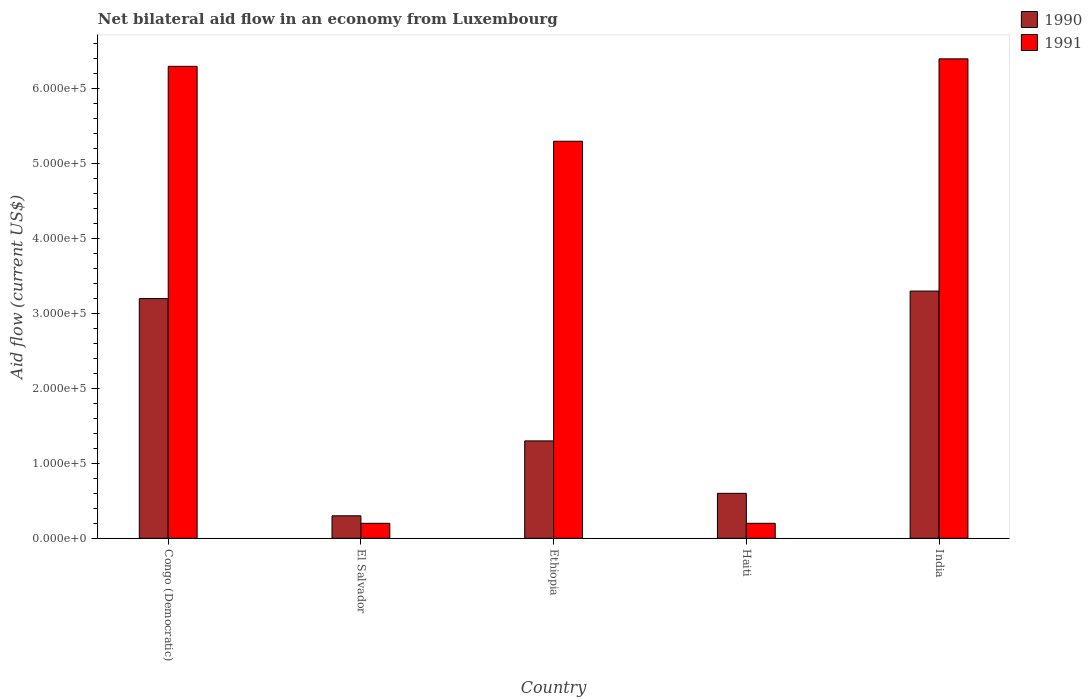How many groups of bars are there?
Offer a very short reply. 5. Are the number of bars per tick equal to the number of legend labels?
Your answer should be compact. Yes. Are the number of bars on each tick of the X-axis equal?
Keep it short and to the point. Yes. How many bars are there on the 4th tick from the left?
Your response must be concise. 2. How many bars are there on the 5th tick from the right?
Offer a terse response. 2. What is the label of the 2nd group of bars from the left?
Your answer should be very brief. El Salvador. What is the net bilateral aid flow in 1990 in Ethiopia?
Make the answer very short. 1.30e+05. In which country was the net bilateral aid flow in 1991 minimum?
Give a very brief answer. El Salvador. What is the total net bilateral aid flow in 1991 in the graph?
Offer a very short reply. 1.84e+06. What is the difference between the net bilateral aid flow in 1991 in Haiti and that in India?
Your answer should be compact. -6.20e+05. What is the average net bilateral aid flow in 1991 per country?
Give a very brief answer. 3.68e+05. What is the difference between the net bilateral aid flow of/in 1991 and net bilateral aid flow of/in 1990 in India?
Make the answer very short. 3.10e+05. What is the ratio of the net bilateral aid flow in 1990 in Congo (Democratic) to that in India?
Make the answer very short. 0.97. Is the net bilateral aid flow in 1990 in Congo (Democratic) less than that in Ethiopia?
Make the answer very short. No. What is the difference between the highest and the lowest net bilateral aid flow in 1990?
Your answer should be compact. 3.00e+05. In how many countries, is the net bilateral aid flow in 1991 greater than the average net bilateral aid flow in 1991 taken over all countries?
Keep it short and to the point. 3. What does the 1st bar from the right in Ethiopia represents?
Ensure brevity in your answer.  1991. Are all the bars in the graph horizontal?
Provide a short and direct response. No. How many countries are there in the graph?
Give a very brief answer. 5. Does the graph contain any zero values?
Offer a very short reply. No. Where does the legend appear in the graph?
Offer a terse response. Top right. How many legend labels are there?
Provide a succinct answer. 2. What is the title of the graph?
Provide a succinct answer. Net bilateral aid flow in an economy from Luxembourg. Does "1990" appear as one of the legend labels in the graph?
Ensure brevity in your answer.  Yes. What is the label or title of the X-axis?
Ensure brevity in your answer.  Country. What is the label or title of the Y-axis?
Provide a short and direct response. Aid flow (current US$). What is the Aid flow (current US$) of 1991 in Congo (Democratic)?
Your response must be concise. 6.30e+05. What is the Aid flow (current US$) in 1990 in El Salvador?
Ensure brevity in your answer.  3.00e+04. What is the Aid flow (current US$) in 1991 in Ethiopia?
Your response must be concise. 5.30e+05. What is the Aid flow (current US$) in 1990 in Haiti?
Keep it short and to the point. 6.00e+04. What is the Aid flow (current US$) of 1991 in Haiti?
Provide a short and direct response. 2.00e+04. What is the Aid flow (current US$) in 1991 in India?
Your response must be concise. 6.40e+05. Across all countries, what is the maximum Aid flow (current US$) of 1990?
Your response must be concise. 3.30e+05. Across all countries, what is the maximum Aid flow (current US$) of 1991?
Ensure brevity in your answer.  6.40e+05. What is the total Aid flow (current US$) in 1990 in the graph?
Keep it short and to the point. 8.70e+05. What is the total Aid flow (current US$) of 1991 in the graph?
Give a very brief answer. 1.84e+06. What is the difference between the Aid flow (current US$) of 1990 in Congo (Democratic) and that in El Salvador?
Offer a terse response. 2.90e+05. What is the difference between the Aid flow (current US$) in 1991 in Congo (Democratic) and that in El Salvador?
Offer a terse response. 6.10e+05. What is the difference between the Aid flow (current US$) of 1990 in Congo (Democratic) and that in Haiti?
Give a very brief answer. 2.60e+05. What is the difference between the Aid flow (current US$) in 1990 in El Salvador and that in Ethiopia?
Make the answer very short. -1.00e+05. What is the difference between the Aid flow (current US$) in 1991 in El Salvador and that in Ethiopia?
Your response must be concise. -5.10e+05. What is the difference between the Aid flow (current US$) in 1990 in El Salvador and that in Haiti?
Your response must be concise. -3.00e+04. What is the difference between the Aid flow (current US$) in 1991 in El Salvador and that in Haiti?
Provide a short and direct response. 0. What is the difference between the Aid flow (current US$) in 1991 in El Salvador and that in India?
Your answer should be compact. -6.20e+05. What is the difference between the Aid flow (current US$) of 1991 in Ethiopia and that in Haiti?
Your response must be concise. 5.10e+05. What is the difference between the Aid flow (current US$) of 1991 in Ethiopia and that in India?
Provide a succinct answer. -1.10e+05. What is the difference between the Aid flow (current US$) of 1990 in Haiti and that in India?
Make the answer very short. -2.70e+05. What is the difference between the Aid flow (current US$) of 1991 in Haiti and that in India?
Your response must be concise. -6.20e+05. What is the difference between the Aid flow (current US$) of 1990 in Congo (Democratic) and the Aid flow (current US$) of 1991 in Ethiopia?
Your answer should be compact. -2.10e+05. What is the difference between the Aid flow (current US$) in 1990 in Congo (Democratic) and the Aid flow (current US$) in 1991 in Haiti?
Provide a succinct answer. 3.00e+05. What is the difference between the Aid flow (current US$) in 1990 in Congo (Democratic) and the Aid flow (current US$) in 1991 in India?
Ensure brevity in your answer.  -3.20e+05. What is the difference between the Aid flow (current US$) of 1990 in El Salvador and the Aid flow (current US$) of 1991 in Ethiopia?
Your answer should be very brief. -5.00e+05. What is the difference between the Aid flow (current US$) of 1990 in El Salvador and the Aid flow (current US$) of 1991 in Haiti?
Provide a short and direct response. 10000. What is the difference between the Aid flow (current US$) of 1990 in El Salvador and the Aid flow (current US$) of 1991 in India?
Make the answer very short. -6.10e+05. What is the difference between the Aid flow (current US$) in 1990 in Ethiopia and the Aid flow (current US$) in 1991 in India?
Give a very brief answer. -5.10e+05. What is the difference between the Aid flow (current US$) of 1990 in Haiti and the Aid flow (current US$) of 1991 in India?
Offer a terse response. -5.80e+05. What is the average Aid flow (current US$) of 1990 per country?
Make the answer very short. 1.74e+05. What is the average Aid flow (current US$) in 1991 per country?
Provide a short and direct response. 3.68e+05. What is the difference between the Aid flow (current US$) of 1990 and Aid flow (current US$) of 1991 in Congo (Democratic)?
Provide a succinct answer. -3.10e+05. What is the difference between the Aid flow (current US$) in 1990 and Aid flow (current US$) in 1991 in El Salvador?
Offer a terse response. 10000. What is the difference between the Aid flow (current US$) in 1990 and Aid flow (current US$) in 1991 in Ethiopia?
Your answer should be very brief. -4.00e+05. What is the difference between the Aid flow (current US$) of 1990 and Aid flow (current US$) of 1991 in Haiti?
Offer a terse response. 4.00e+04. What is the difference between the Aid flow (current US$) of 1990 and Aid flow (current US$) of 1991 in India?
Your answer should be compact. -3.10e+05. What is the ratio of the Aid flow (current US$) in 1990 in Congo (Democratic) to that in El Salvador?
Offer a very short reply. 10.67. What is the ratio of the Aid flow (current US$) in 1991 in Congo (Democratic) to that in El Salvador?
Provide a succinct answer. 31.5. What is the ratio of the Aid flow (current US$) of 1990 in Congo (Democratic) to that in Ethiopia?
Give a very brief answer. 2.46. What is the ratio of the Aid flow (current US$) of 1991 in Congo (Democratic) to that in Ethiopia?
Keep it short and to the point. 1.19. What is the ratio of the Aid flow (current US$) in 1990 in Congo (Democratic) to that in Haiti?
Your answer should be compact. 5.33. What is the ratio of the Aid flow (current US$) of 1991 in Congo (Democratic) to that in Haiti?
Your answer should be compact. 31.5. What is the ratio of the Aid flow (current US$) in 1990 in Congo (Democratic) to that in India?
Give a very brief answer. 0.97. What is the ratio of the Aid flow (current US$) in 1991 in Congo (Democratic) to that in India?
Keep it short and to the point. 0.98. What is the ratio of the Aid flow (current US$) in 1990 in El Salvador to that in Ethiopia?
Make the answer very short. 0.23. What is the ratio of the Aid flow (current US$) of 1991 in El Salvador to that in Ethiopia?
Give a very brief answer. 0.04. What is the ratio of the Aid flow (current US$) in 1990 in El Salvador to that in India?
Make the answer very short. 0.09. What is the ratio of the Aid flow (current US$) in 1991 in El Salvador to that in India?
Your answer should be compact. 0.03. What is the ratio of the Aid flow (current US$) in 1990 in Ethiopia to that in Haiti?
Your answer should be compact. 2.17. What is the ratio of the Aid flow (current US$) in 1990 in Ethiopia to that in India?
Offer a very short reply. 0.39. What is the ratio of the Aid flow (current US$) in 1991 in Ethiopia to that in India?
Ensure brevity in your answer.  0.83. What is the ratio of the Aid flow (current US$) in 1990 in Haiti to that in India?
Ensure brevity in your answer.  0.18. What is the ratio of the Aid flow (current US$) in 1991 in Haiti to that in India?
Your answer should be very brief. 0.03. What is the difference between the highest and the second highest Aid flow (current US$) in 1990?
Offer a very short reply. 10000. What is the difference between the highest and the lowest Aid flow (current US$) in 1990?
Keep it short and to the point. 3.00e+05. What is the difference between the highest and the lowest Aid flow (current US$) of 1991?
Give a very brief answer. 6.20e+05. 